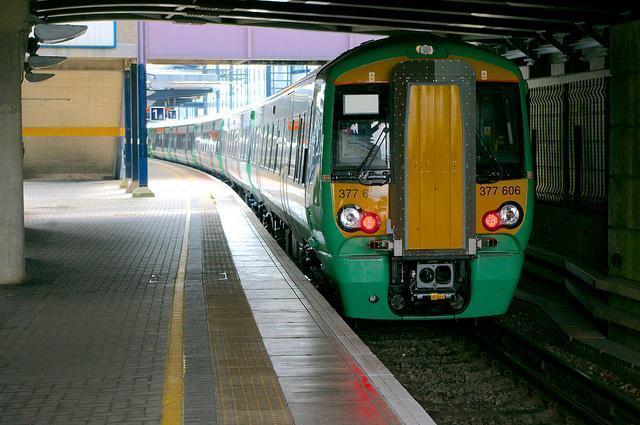How many trains are pulling into the station?
Give a very brief answer. 1. How many giraffes are reaching for the branch?
Give a very brief answer. 0. 